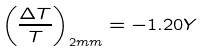<formula> <loc_0><loc_0><loc_500><loc_500>\left ( \frac { \Delta T } { T } \right ) _ { 2 m m } = - 1 . 2 0 Y</formula> 